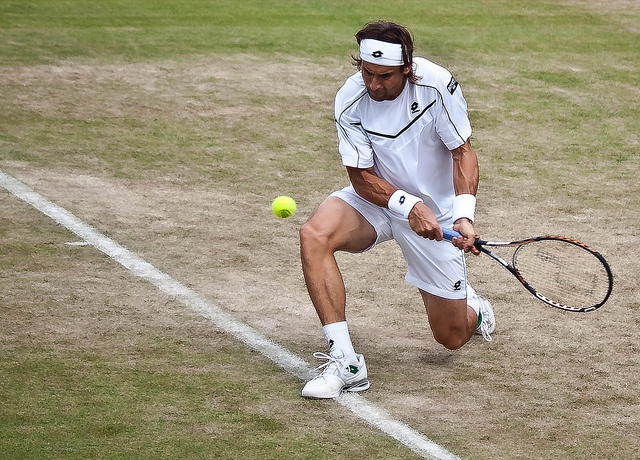Describe the objects in this image and their specific colors. I can see people in olive, lavender, darkgray, and brown tones, tennis racket in olive, darkgray, tan, and black tones, and sports ball in olive, yellow, and khaki tones in this image. 